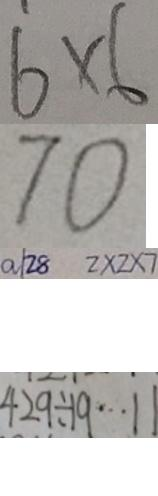<formula> <loc_0><loc_0><loc_500><loc_500>6 \times 6 
 7 0 
 a / 2 8 2 \times 2 \times 2 \times 7 
 4 9 2 \div 1 9 \cdots 1 1</formula> 